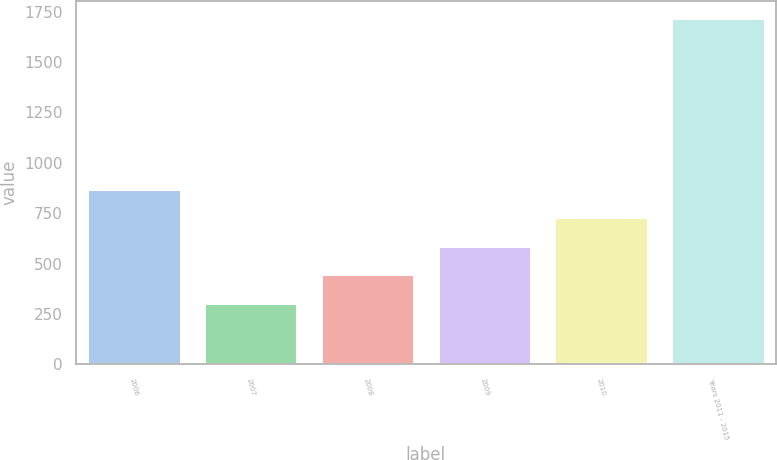<chart> <loc_0><loc_0><loc_500><loc_500><bar_chart><fcel>2006<fcel>2007<fcel>2008<fcel>2009<fcel>2010<fcel>Years 2011 - 2015<nl><fcel>870.6<fcel>305<fcel>446.4<fcel>587.8<fcel>729.2<fcel>1719<nl></chart> 